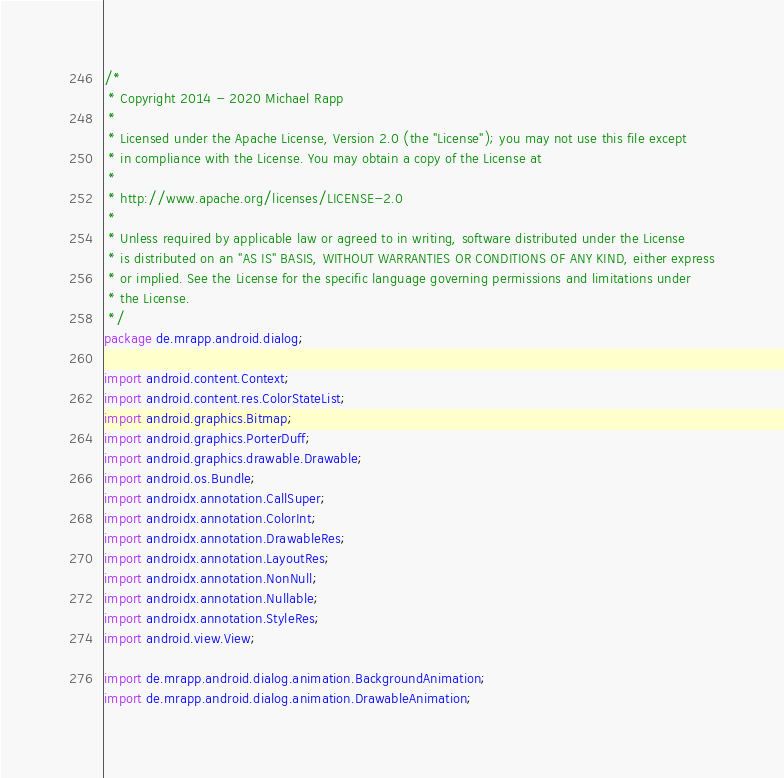<code> <loc_0><loc_0><loc_500><loc_500><_Java_>/*
 * Copyright 2014 - 2020 Michael Rapp
 *
 * Licensed under the Apache License, Version 2.0 (the "License"); you may not use this file except
 * in compliance with the License. You may obtain a copy of the License at
 *
 * http://www.apache.org/licenses/LICENSE-2.0
 *
 * Unless required by applicable law or agreed to in writing, software distributed under the License
 * is distributed on an "AS IS" BASIS, WITHOUT WARRANTIES OR CONDITIONS OF ANY KIND, either express
 * or implied. See the License for the specific language governing permissions and limitations under
 * the License.
 */
package de.mrapp.android.dialog;

import android.content.Context;
import android.content.res.ColorStateList;
import android.graphics.Bitmap;
import android.graphics.PorterDuff;
import android.graphics.drawable.Drawable;
import android.os.Bundle;
import androidx.annotation.CallSuper;
import androidx.annotation.ColorInt;
import androidx.annotation.DrawableRes;
import androidx.annotation.LayoutRes;
import androidx.annotation.NonNull;
import androidx.annotation.Nullable;
import androidx.annotation.StyleRes;
import android.view.View;

import de.mrapp.android.dialog.animation.BackgroundAnimation;
import de.mrapp.android.dialog.animation.DrawableAnimation;</code> 